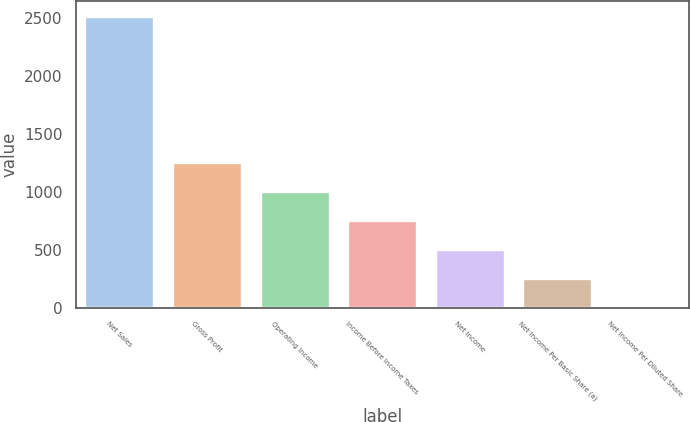Convert chart. <chart><loc_0><loc_0><loc_500><loc_500><bar_chart><fcel>Net Sales<fcel>Gross Profit<fcel>Operating Income<fcel>Income Before Income Taxes<fcel>Net Income<fcel>Net Income Per Basic Share (a)<fcel>Net Income Per Diluted Share<nl><fcel>2516<fcel>1258.31<fcel>1006.77<fcel>755.23<fcel>503.69<fcel>252.15<fcel>0.61<nl></chart> 